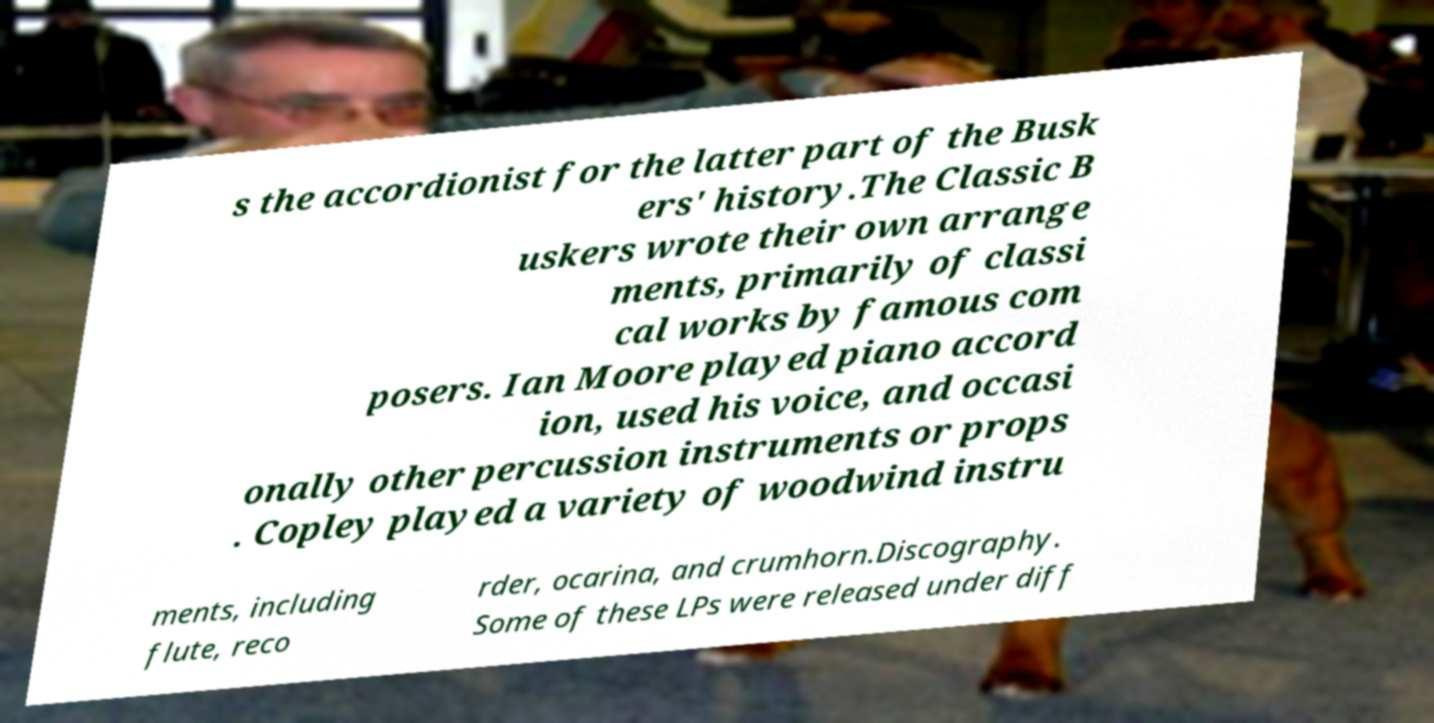Could you assist in decoding the text presented in this image and type it out clearly? s the accordionist for the latter part of the Busk ers' history.The Classic B uskers wrote their own arrange ments, primarily of classi cal works by famous com posers. Ian Moore played piano accord ion, used his voice, and occasi onally other percussion instruments or props . Copley played a variety of woodwind instru ments, including flute, reco rder, ocarina, and crumhorn.Discography. Some of these LPs were released under diff 